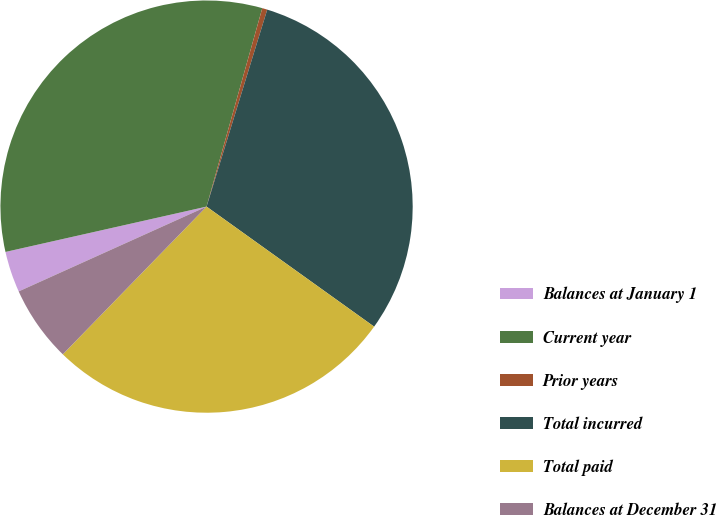Convert chart. <chart><loc_0><loc_0><loc_500><loc_500><pie_chart><fcel>Balances at January 1<fcel>Current year<fcel>Prior years<fcel>Total incurred<fcel>Total paid<fcel>Balances at December 31<nl><fcel>3.22%<fcel>32.89%<fcel>0.4%<fcel>30.14%<fcel>27.39%<fcel>5.97%<nl></chart> 